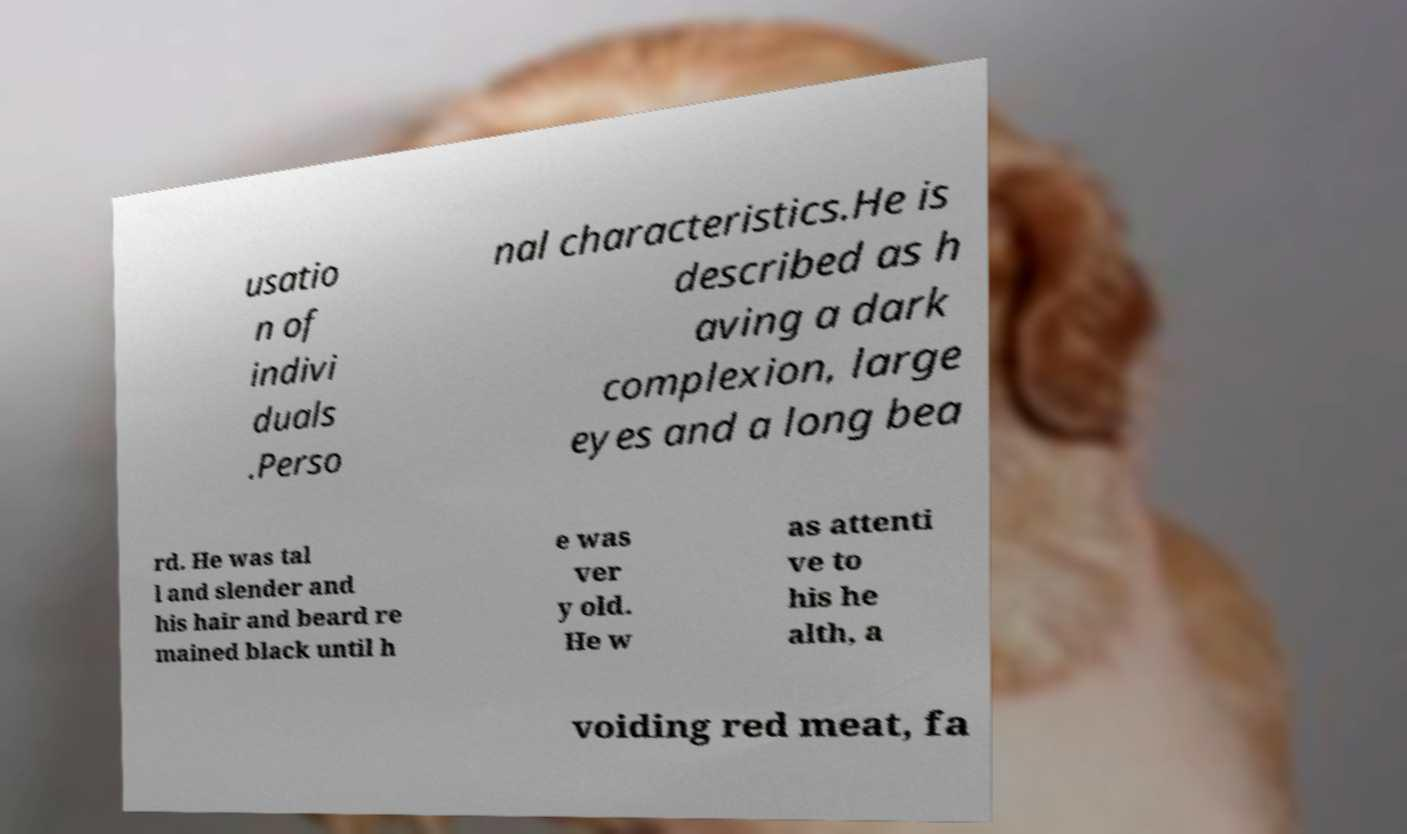I need the written content from this picture converted into text. Can you do that? usatio n of indivi duals .Perso nal characteristics.He is described as h aving a dark complexion, large eyes and a long bea rd. He was tal l and slender and his hair and beard re mained black until h e was ver y old. He w as attenti ve to his he alth, a voiding red meat, fa 